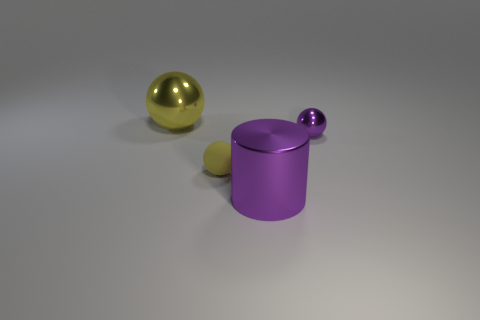Add 2 big cyan rubber balls. How many objects exist? 6 Subtract all balls. How many objects are left? 1 Add 4 big purple cylinders. How many big purple cylinders exist? 5 Subtract 0 gray cylinders. How many objects are left? 4 Subtract all blue cubes. Subtract all big purple objects. How many objects are left? 3 Add 3 metallic spheres. How many metallic spheres are left? 5 